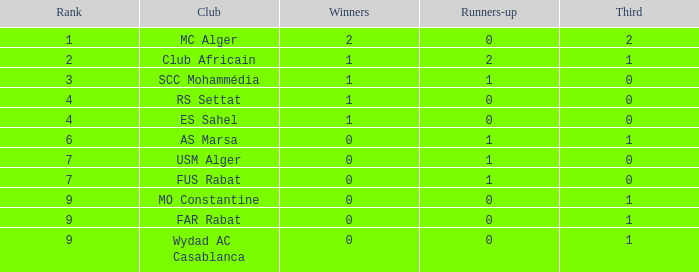What rank has a third of 2 and winners with values less than 2? None. 